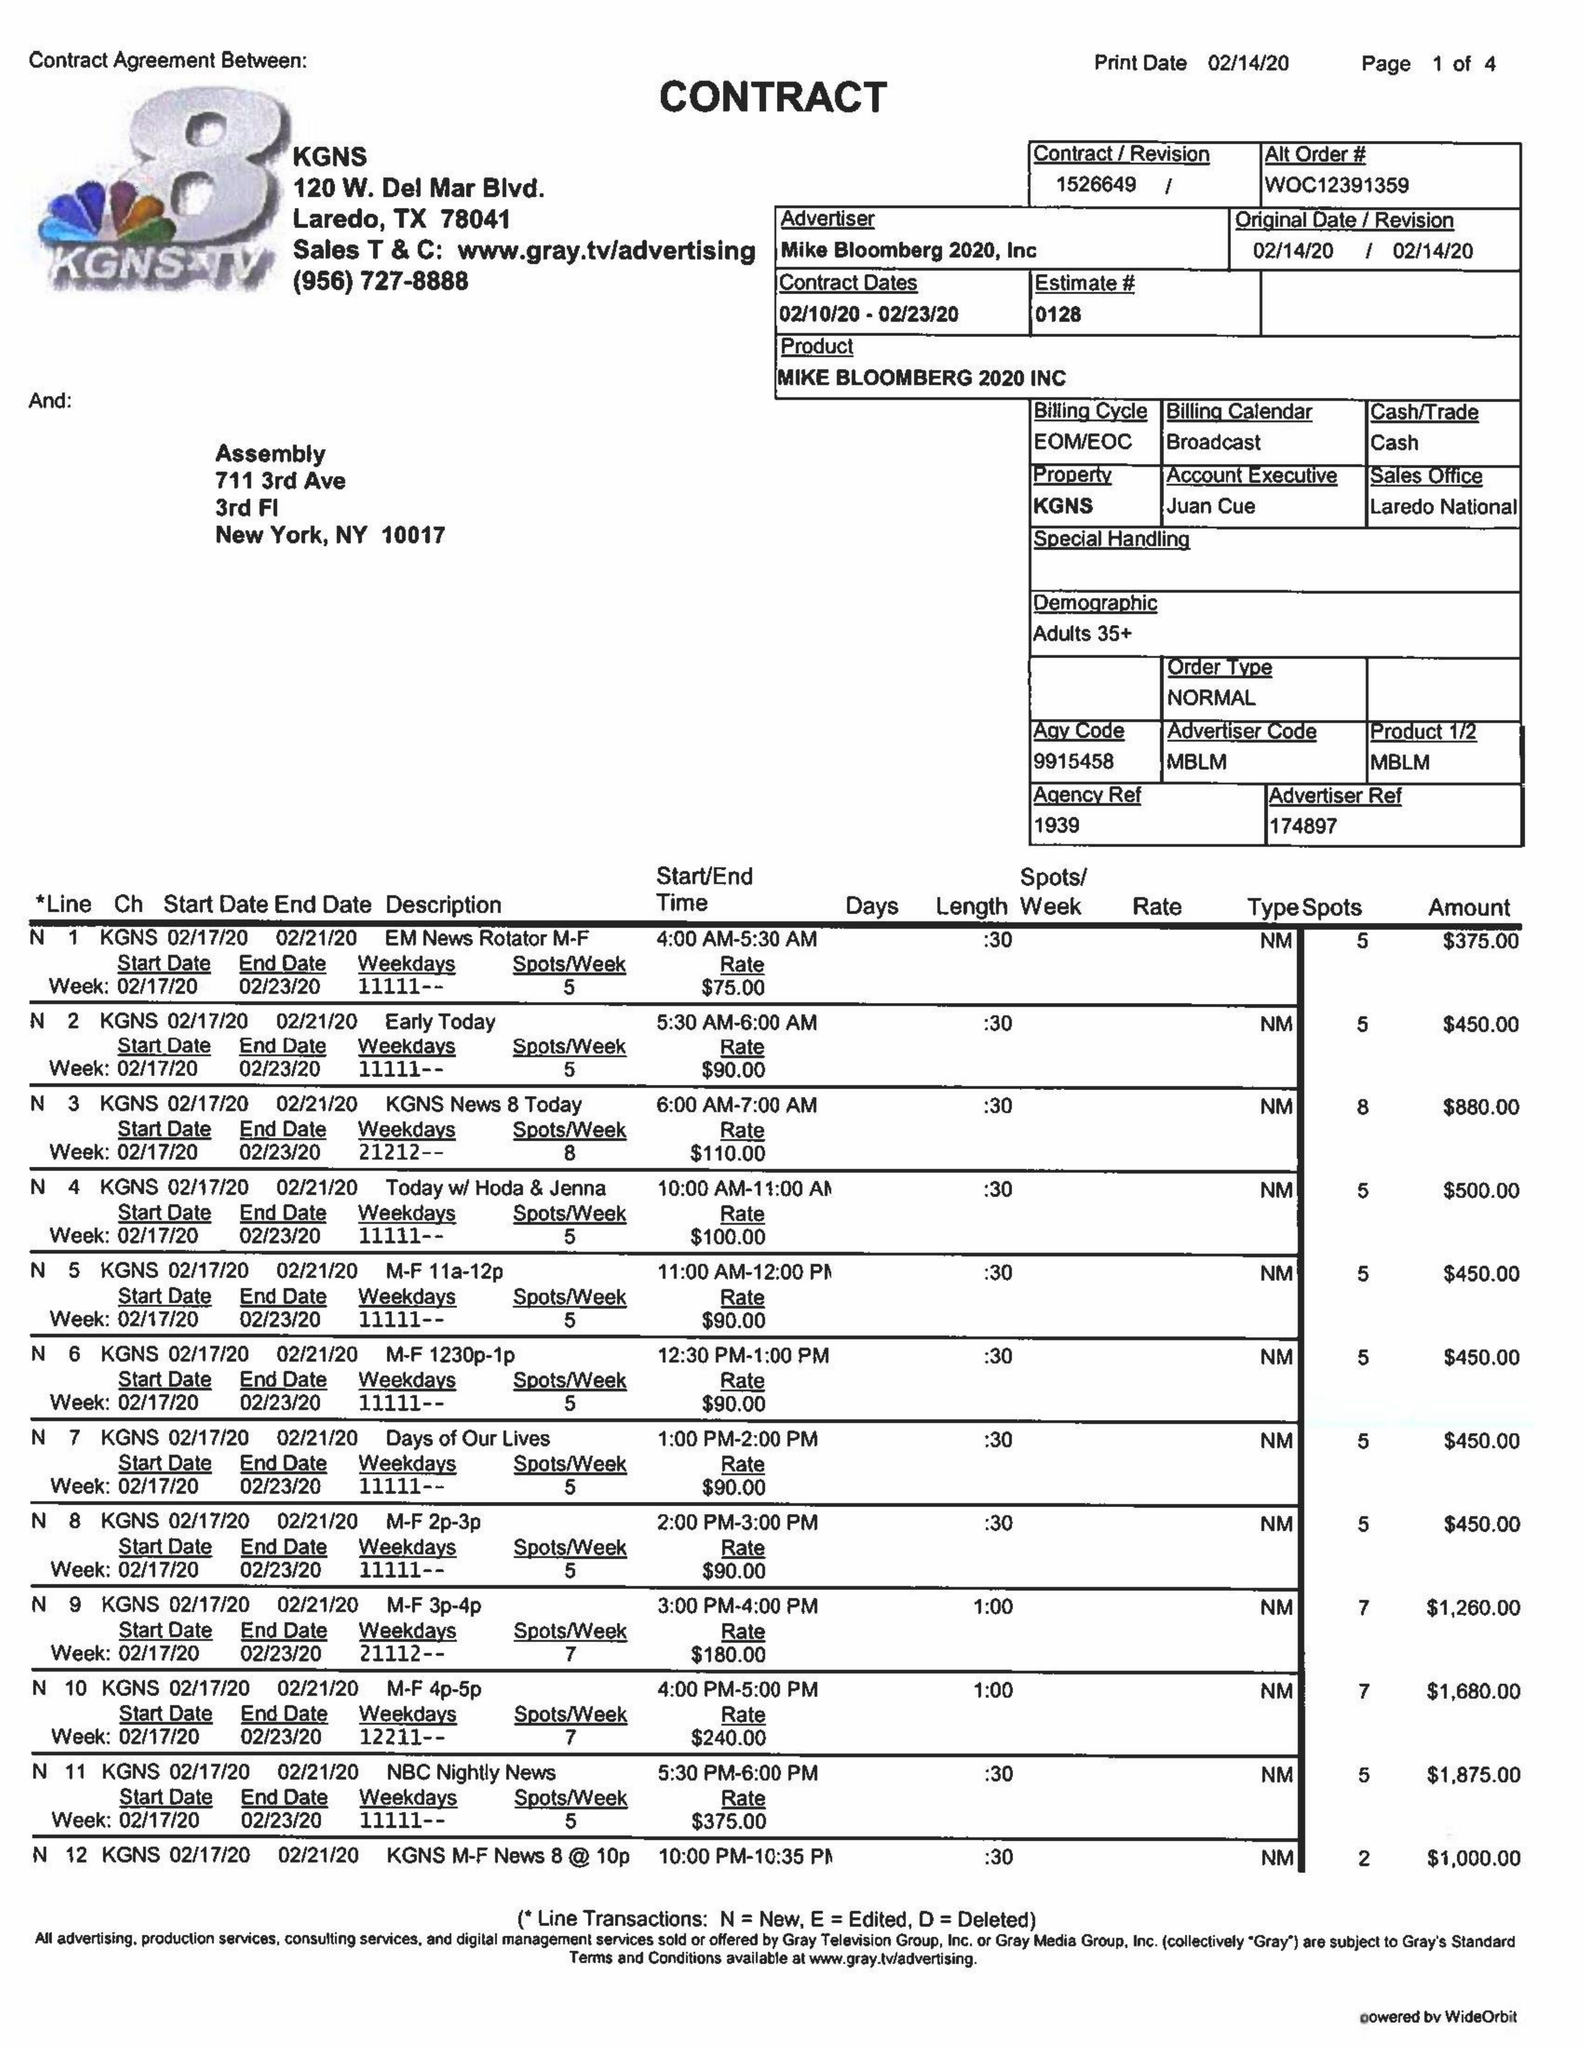What is the value for the advertiser?
Answer the question using a single word or phrase. MIKE BLOOMBERG 2020, INC 